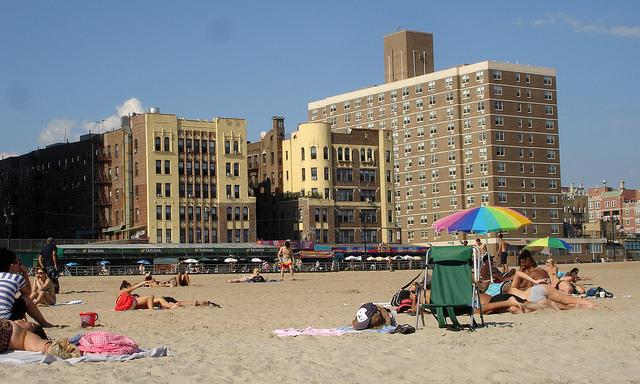What color are the buildings in the background?
Answer briefly. Brown. How many balconies are visible on the building in the pic?
Give a very brief answer. 0. Where was the photo taken?
Concise answer only. Beach. What is the color of the umbrellas?
Short answer required. Rainbow. 